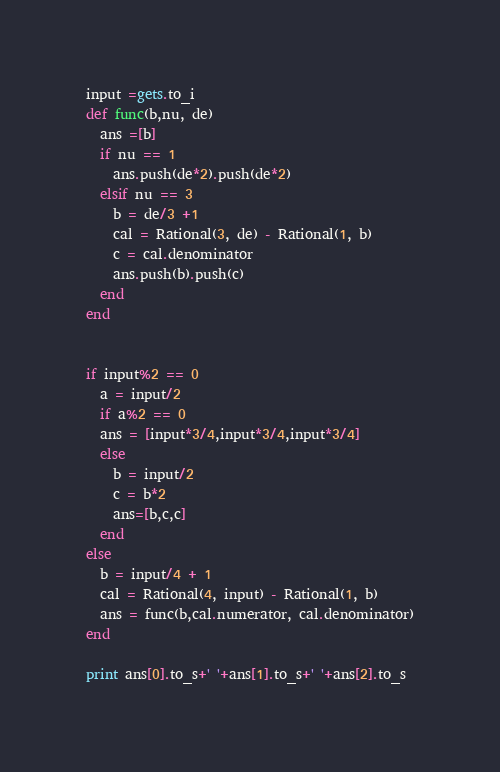Convert code to text. <code><loc_0><loc_0><loc_500><loc_500><_Ruby_>input =gets.to_i
def func(b,nu, de)
  ans =[b]
  if nu == 1
    ans.push(de*2).push(de*2)
  elsif nu == 3
    b = de/3 +1
    cal = Rational(3, de) - Rational(1, b)
    c = cal.denominator
    ans.push(b).push(c)
  end
end


if input%2 == 0
  a = input/2
  if a%2 == 0
  ans = [input*3/4,input*3/4,input*3/4]
  else
    b = input/2
    c = b*2
    ans=[b,c,c]
  end
else
  b = input/4 + 1
  cal = Rational(4, input) - Rational(1, b)
  ans = func(b,cal.numerator, cal.denominator)
end

print ans[0].to_s+' '+ans[1].to_s+' '+ans[2].to_s</code> 